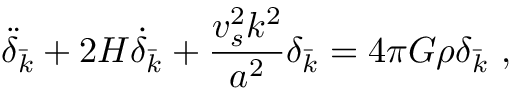Convert formula to latex. <formula><loc_0><loc_0><loc_500><loc_500>\ddot { \delta } _ { \bar { k } } + 2 H \dot { \delta } _ { \bar { k } } + \frac { v _ { s } ^ { 2 } k ^ { 2 } } { a ^ { 2 } } \delta _ { \bar { k } } = 4 \pi G \rho \delta _ { \bar { k } } ,</formula> 